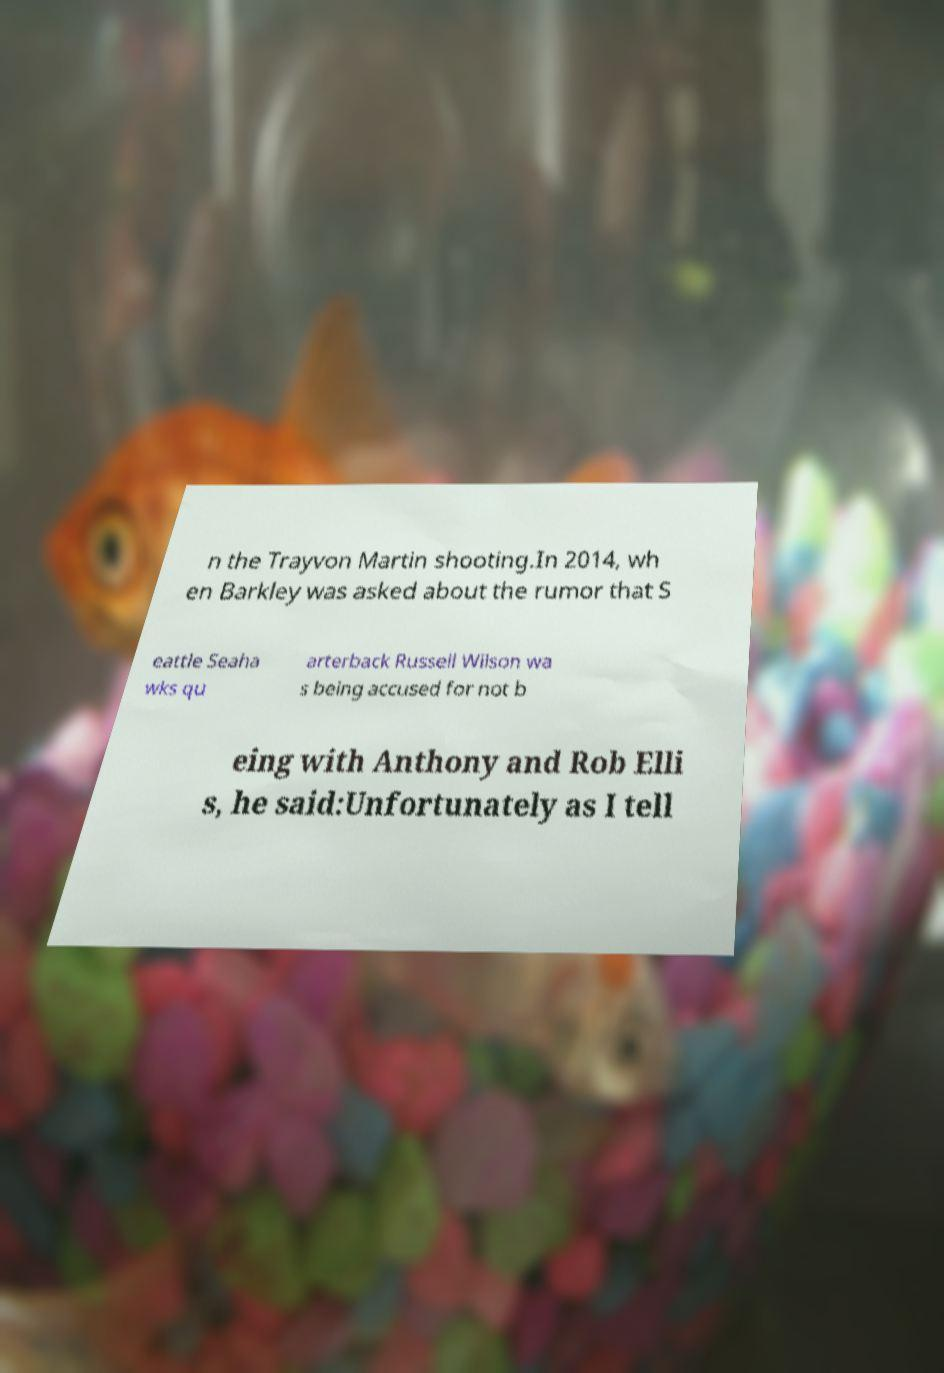Please identify and transcribe the text found in this image. n the Trayvon Martin shooting.In 2014, wh en Barkley was asked about the rumor that S eattle Seaha wks qu arterback Russell Wilson wa s being accused for not b eing with Anthony and Rob Elli s, he said:Unfortunately as I tell 